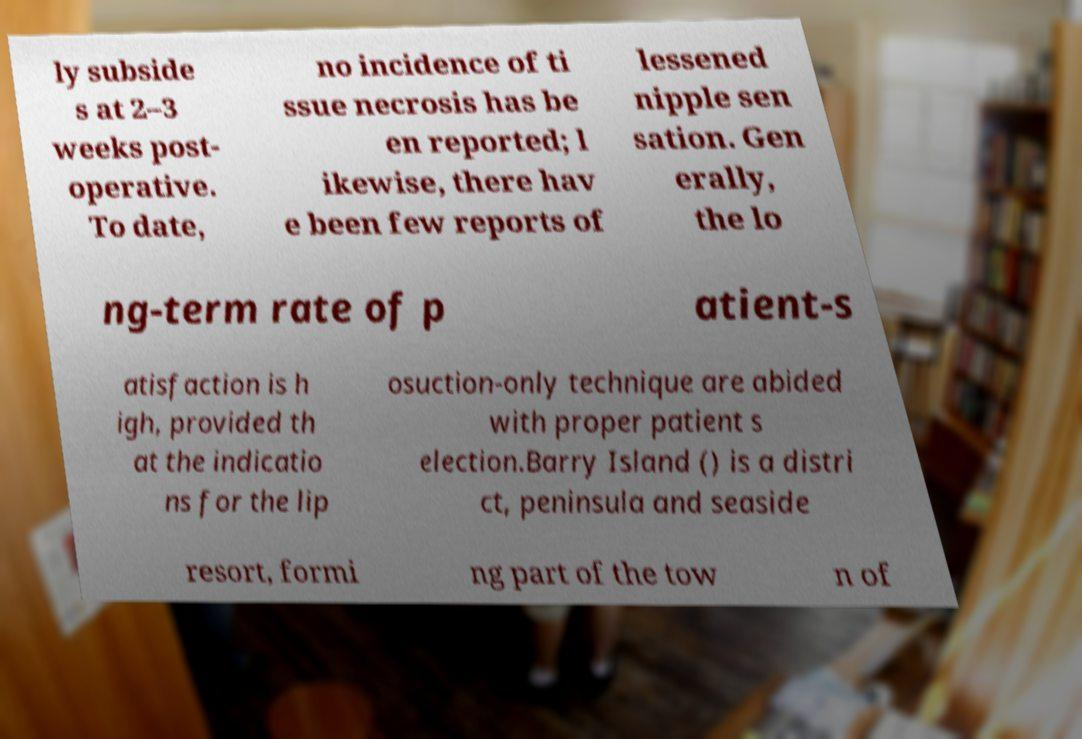Can you read and provide the text displayed in the image?This photo seems to have some interesting text. Can you extract and type it out for me? ly subside s at 2–3 weeks post- operative. To date, no incidence of ti ssue necrosis has be en reported; l ikewise, there hav e been few reports of lessened nipple sen sation. Gen erally, the lo ng-term rate of p atient-s atisfaction is h igh, provided th at the indicatio ns for the lip osuction-only technique are abided with proper patient s election.Barry Island () is a distri ct, peninsula and seaside resort, formi ng part of the tow n of 